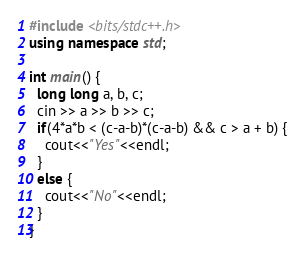<code> <loc_0><loc_0><loc_500><loc_500><_C++_>#include <bits/stdc++.h>
using namespace std;

int main() {
  long long a, b, c;
  cin >> a >> b >> c;
  if(4*a*b < (c-a-b)*(c-a-b) && c > a + b) {
    cout<<"Yes"<<endl;
  }
  else {
    cout<<"No"<<endl;
  }
}
</code> 